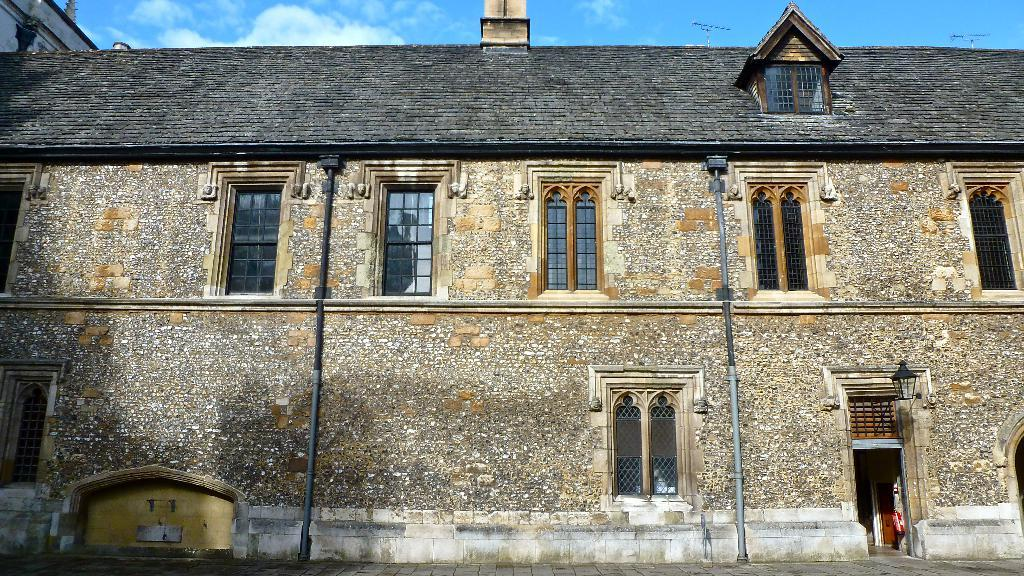What type of building is in the image? There is a stone building in the image. What feature of the building allows access to the interior? There is a door in the building. Is there any lighting source near the building? Yes, there is a lamp at the right side of the building. How can one see inside the building? There are windows in the building. What type of vacation is being advertised on the building in the image? There is no indication of a vacation being advertised on the building in the image. 